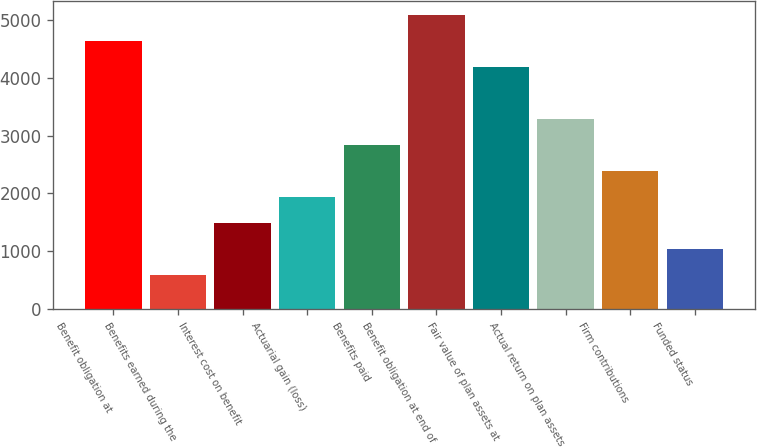Convert chart to OTSL. <chart><loc_0><loc_0><loc_500><loc_500><bar_chart><fcel>Benefit obligation at<fcel>Benefits earned during the<fcel>Interest cost on benefit<fcel>Actuarial gain (loss)<fcel>Benefits paid<fcel>Benefit obligation at end of<fcel>Fair value of plan assets at<fcel>Actual return on plan assets<fcel>Firm contributions<fcel>Funded status<nl><fcel>4633<fcel>586.6<fcel>1485.8<fcel>1935.4<fcel>2834.6<fcel>5082.6<fcel>4183.4<fcel>3284.2<fcel>2385<fcel>1036.2<nl></chart> 